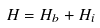Convert formula to latex. <formula><loc_0><loc_0><loc_500><loc_500>H = H _ { b } + H _ { i }</formula> 